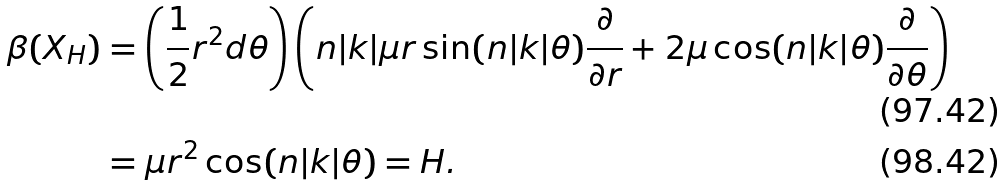<formula> <loc_0><loc_0><loc_500><loc_500>\beta ( X _ { H } ) & = \left ( \frac { 1 } { 2 } r ^ { 2 } d \theta \right ) \left ( n | k | \mu r \sin ( n | k | \theta ) \frac { \partial } { \partial r } + 2 \mu \cos ( n | k | \theta ) \frac { \partial } { \partial \theta } \right ) \\ & = \mu r ^ { 2 } \cos ( n | k | \theta ) = H .</formula> 